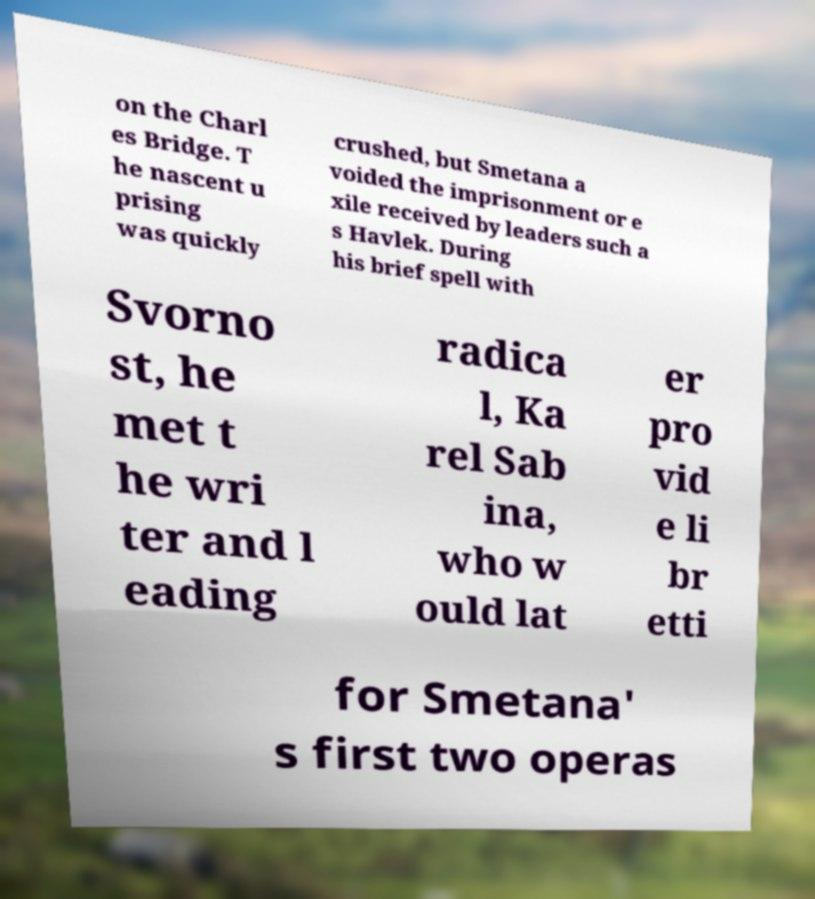Could you assist in decoding the text presented in this image and type it out clearly? on the Charl es Bridge. T he nascent u prising was quickly crushed, but Smetana a voided the imprisonment or e xile received by leaders such a s Havlek. During his brief spell with Svorno st, he met t he wri ter and l eading radica l, Ka rel Sab ina, who w ould lat er pro vid e li br etti for Smetana' s first two operas 